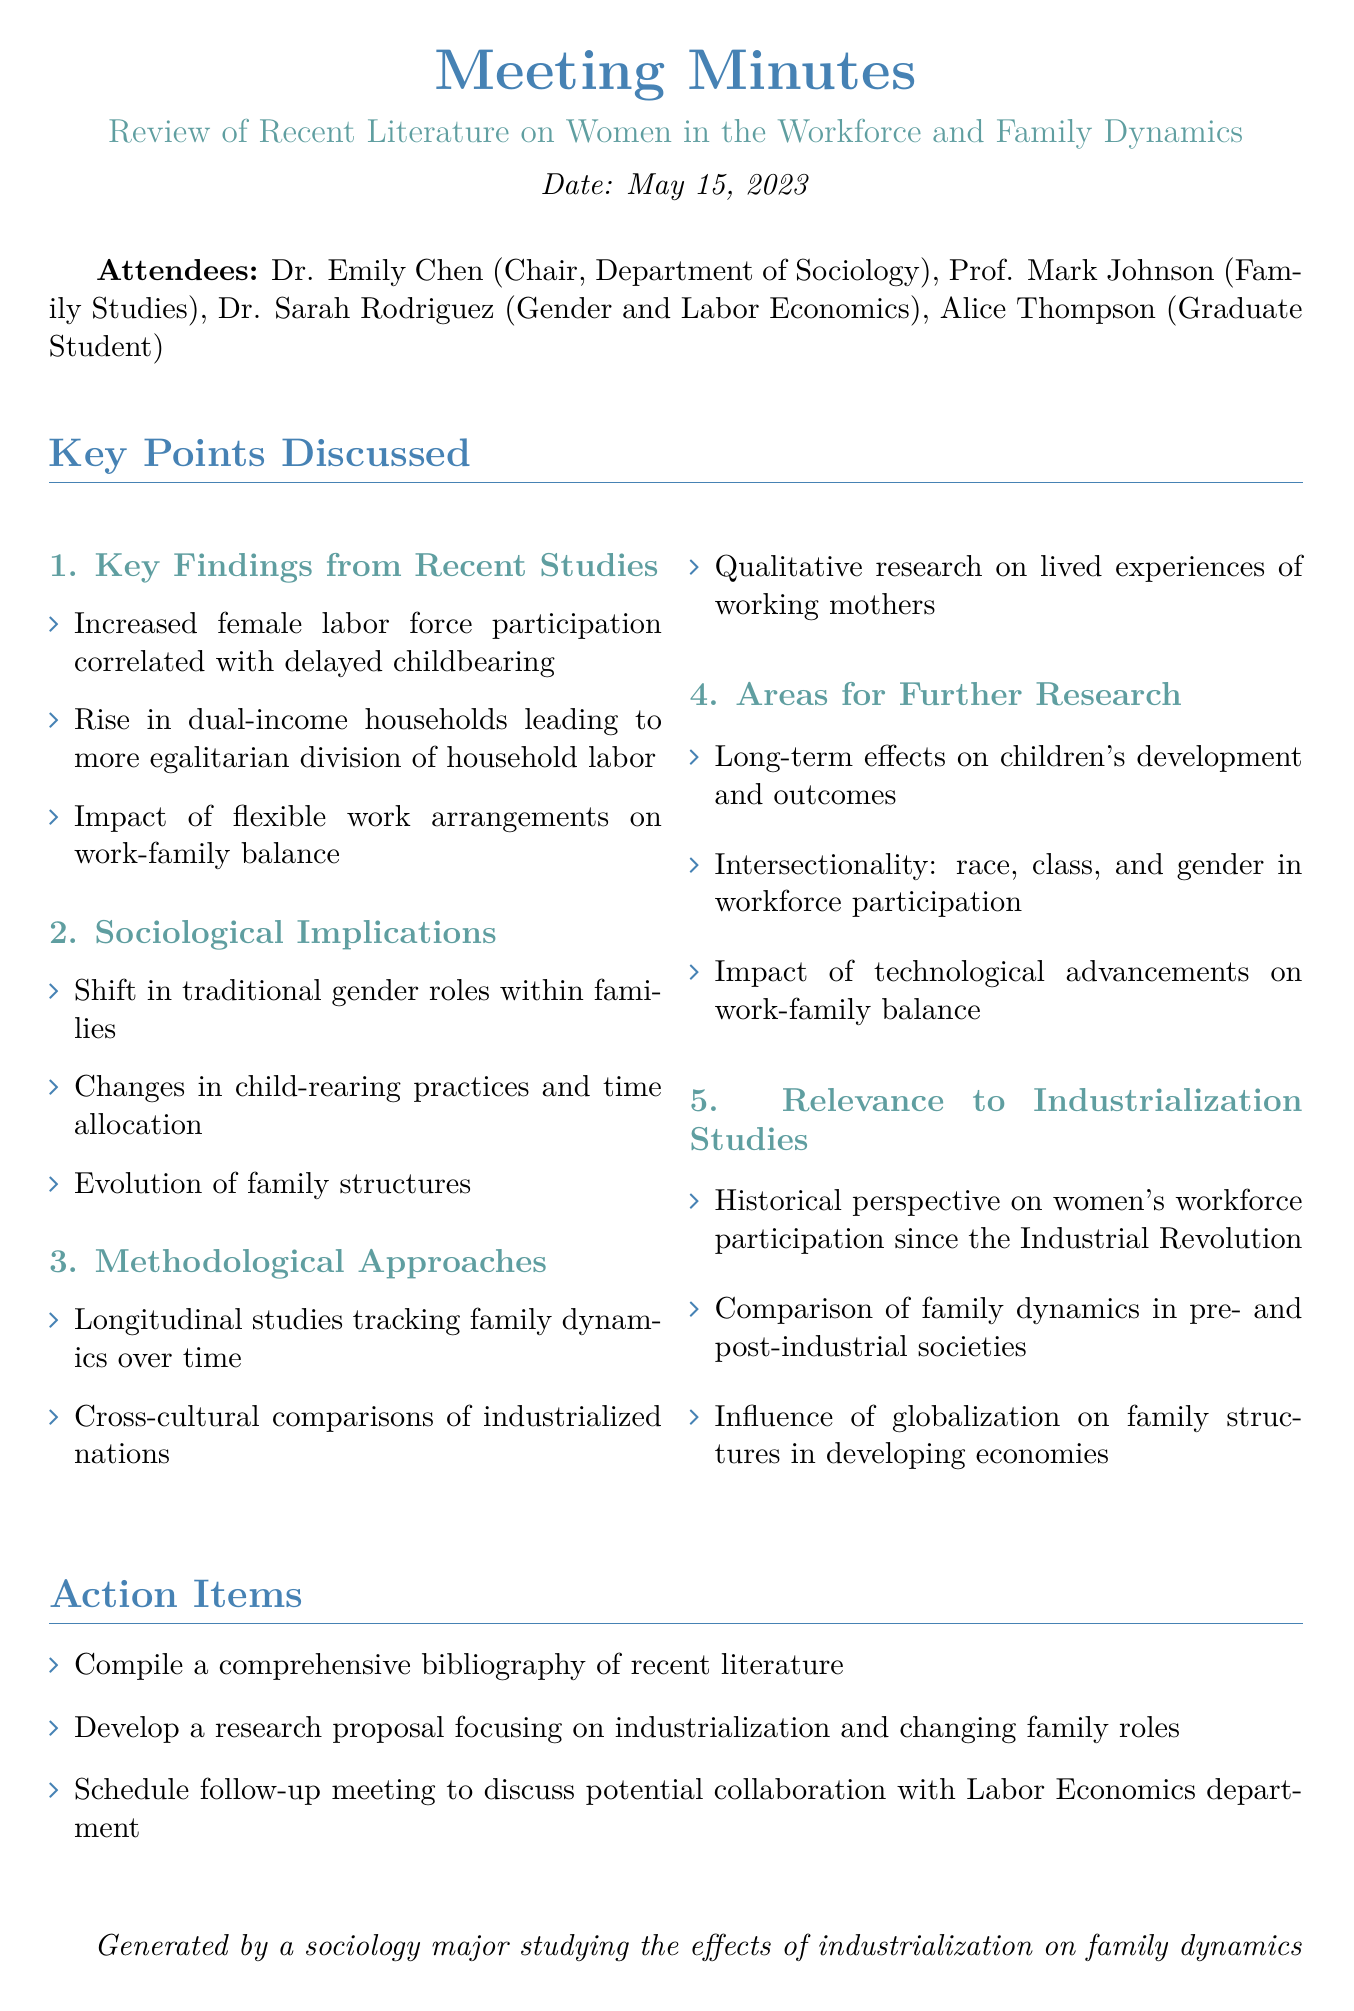What is the meeting date? The meeting date is explicitly mentioned in the document, which is May 15, 2023.
Answer: May 15, 2023 Who chaired the meeting? The document lists Dr. Emily Chen as the chair of the meeting in the attendees section.
Answer: Dr. Emily Chen What is one of the key findings regarding female labor force participation? The document highlights one key finding about increased female labor force participation correlated with delayed childbearing.
Answer: Delayed childbearing What type of studies are mentioned as methodological approaches? The document outlines methodological approaches, including longitudinal studies that track family dynamics over time.
Answer: Longitudinal studies What is an area for further research stated in the document? The document lists several areas for further research, including the long-term effects on children's development and outcomes.
Answer: Long-term effects on children's development What are the attendees' professions primarily related to? The attendees’ professions are primarily related to sociology and family studies, as seen in their titles.
Answer: Sociology and family studies Which concept relates to changes in family structures? The document discusses the evolution of family structures as a sociological implication of women's changing roles in the workforce.
Answer: Evolution of family structures How many action items are listed in the meeting minutes? The document details three action items that were decided upon during the meeting.
Answer: Three 